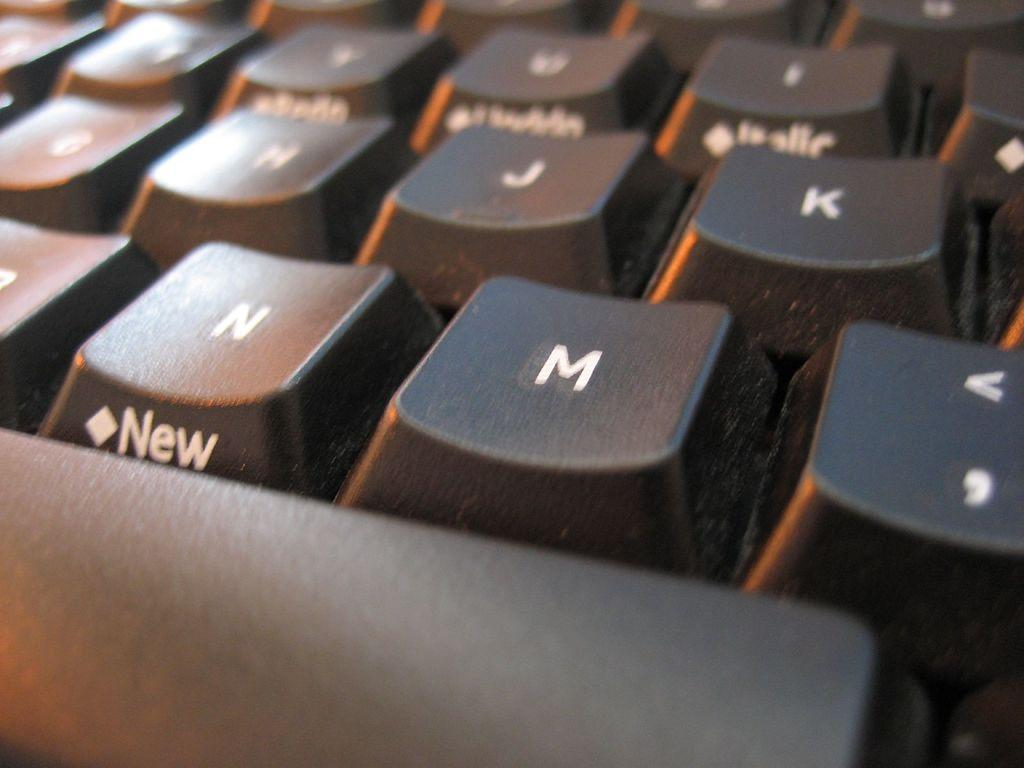What type of device is visible in the image? There is a keyboard in the image. What can be found on the buttons of the keyboard? The keyboard has alphabets on the buttons. Is there any specific word or name on one of the buttons? Yes, there is a name "new" on one of the buttons. What type of lace can be seen on the keyboard in the image? There is no lace present on the keyboard in the image. How does the keyboard express hate in the image? The keyboard does not express hate in the image; it is a neutral device with alphabets and a specific name on one of the buttons. 